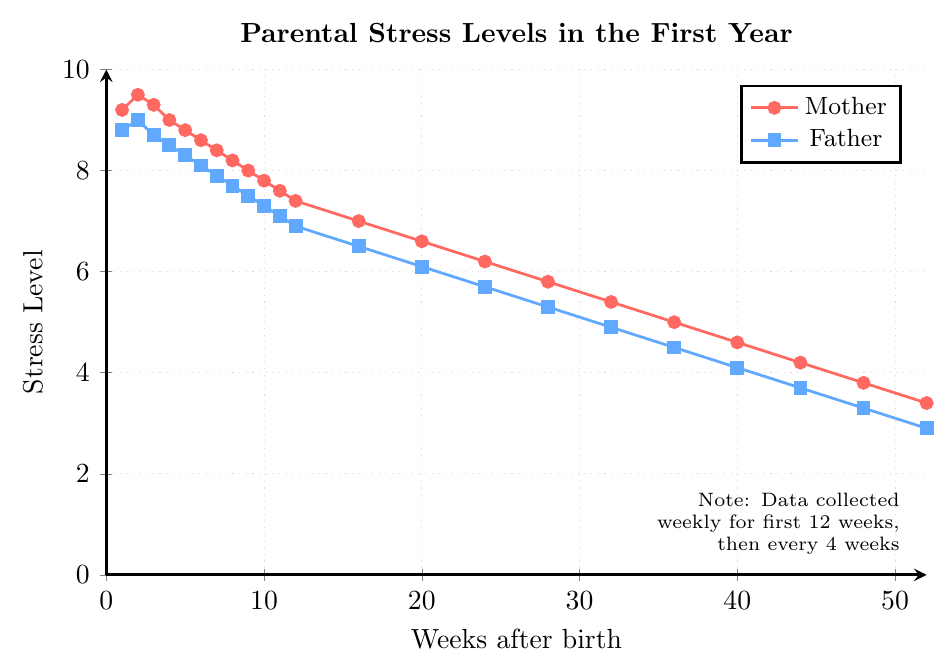What's the highest stress level recorded for the mother? Check the y-axis values for the line representing the mother and identify the peak value. In this case, the highest point on the red line is 9.5.
Answer: 9.5 What's the difference in stress levels between the mother and the father at week 1? Observe the stress levels for the mother and the father at week 1 from the chart. The mother's stress level is 9.2 and the father's is 8.8. Subtract the father's value from the mother's value (9.2 - 8.8).
Answer: 0.4 Comparing week 20 to week 12, which parent shows a greater reduction in stress level? Find the stress levels at week 12 and week 20 for both parents. For the mother: 7.4 (week 12) to 6.6 (week 20) is a reduction of 0.8. For the father: 6.9 (week 12) to 6.1 (week 20) is also a reduction of 0.8. Both parents have the same reduction.
Answer: Neither (equal reduction) How many weeks after birth do the mother's stress levels drop below 6 for the first time? Scan the mother's stress level line to find the week where the value first drops below 6. This occurs at week 28.
Answer: 28 At what week do both parents have an identical stress level? Observe the chart and look for the point where the lines representing the mother’s and father’s stress levels intersect. This occurs at week 2, where both have a stress level of 9.0.
Answer: 2 What's the average stress level of the mother over the first 10 weeks? Add up the mother's stress levels from week 1 to week 10 and then divide by the number of weeks, which is 10. The sum is (9.2 + 9.5 + 9.3 + 9.0 + 8.8 + 8.6 + 8.4 + 8.2 + 8.0 + 7.8) = 87.8. Divide by 10 to get the average.
Answer: 8.78 Compare the initial and final stress levels for both parents. What is the percentage decrease for each? Calculate the difference between initial and final stress levels, then divide by the initial level, finally multiply by 100 to get the percentage. For the mother: (9.2 - 3.4) / 9.2 * 100 ≈ 63.04%. For the father: (8.8 - 2.9) / 8.8 * 100 ≈ 67.05%.
Answer: Mother: 63.04%, Father: 67.05% Describe the visual differences between the mother’s and father’s stress trends over the year. Observe the two lines. The mother's line is consistently above the father's, starting higher and ending higher. The mother’s stress level tends to decrease more gradually and steadily compared to the father's.
Answer: Mother's stress starts higher and decreases gradually, Father's stress starts slightly lower and decreases more rapidly 